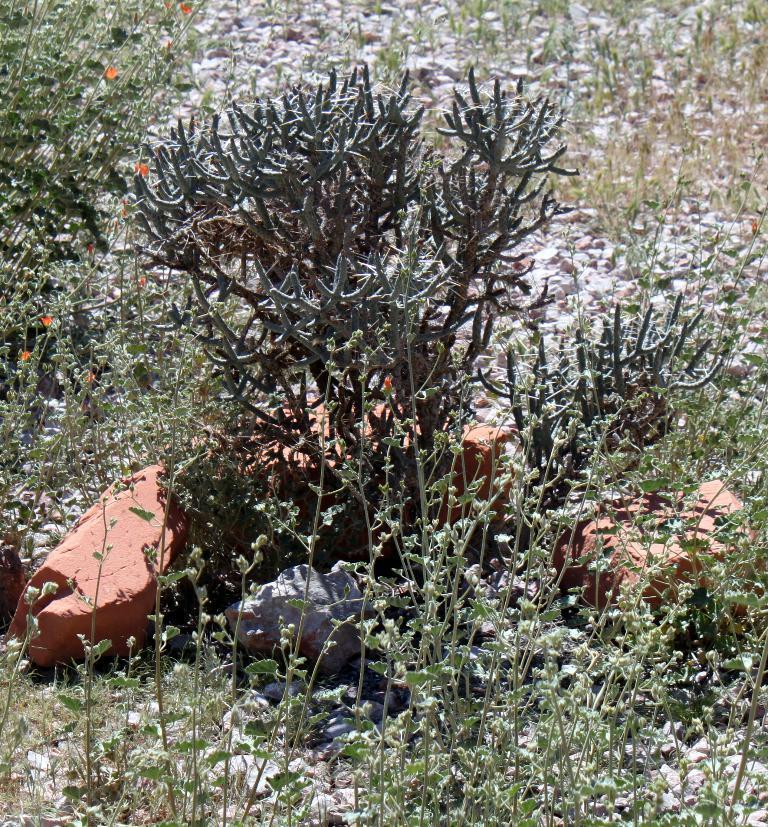In one or two sentences, can you explain what this image depicts? In this image there are two stones at bottom left side of this image and there are some plants in the background. 